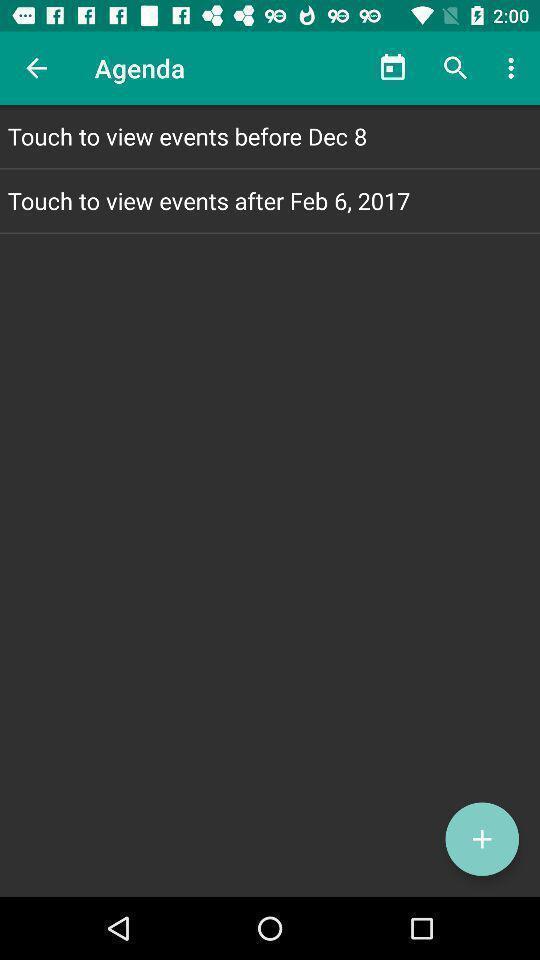Please provide a description for this image. Page for viewing events. 